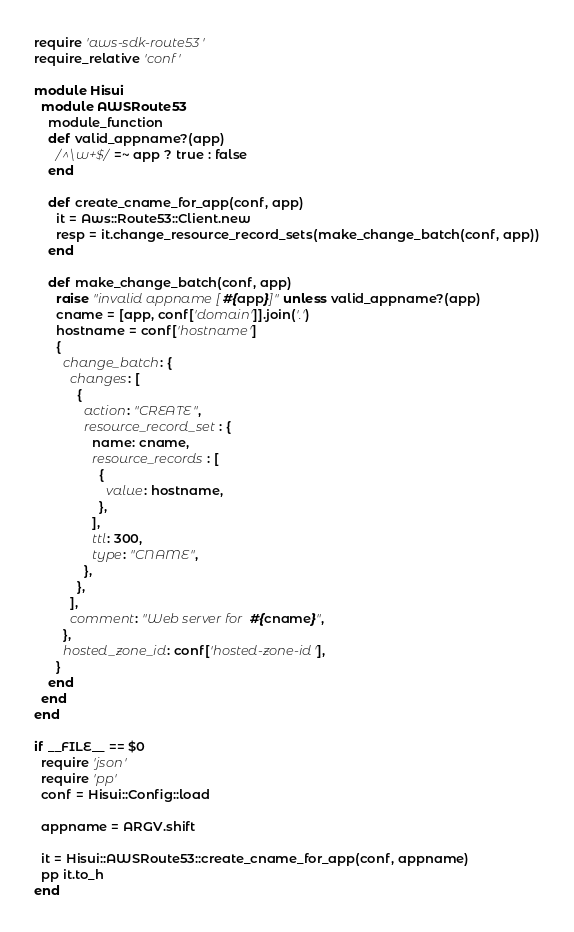Convert code to text. <code><loc_0><loc_0><loc_500><loc_500><_Ruby_>require 'aws-sdk-route53'
require_relative 'conf'

module Hisui
  module AWSRoute53
    module_function
    def valid_appname?(app)
      /^\w+$/ =~ app ? true : false
    end

    def create_cname_for_app(conf, app)
      it = Aws::Route53::Client.new
      resp = it.change_resource_record_sets(make_change_batch(conf, app))
    end

    def make_change_batch(conf, app)
      raise "invalid appname [#{app}]" unless valid_appname?(app)
      cname = [app, conf['domain']].join('.')
      hostname = conf['hostname']
      {
        change_batch: {
          changes: [
            {
              action: "CREATE", 
              resource_record_set: {
                name: cname, 
                resource_records: [
                  {
                    value: hostname, 
                  }, 
                ], 
                ttl: 300, 
                type: "CNAME", 
              }, 
            }, 
          ], 
          comment: "Web server for #{cname}", 
        }, 
        hosted_zone_id: conf['hosted-zone-id'], 
      }
    end
  end
end

if __FILE__ == $0
  require 'json'
  require 'pp'
  conf = Hisui::Config::load

  appname = ARGV.shift

  it = Hisui::AWSRoute53::create_cname_for_app(conf, appname)
  pp it.to_h
end</code> 